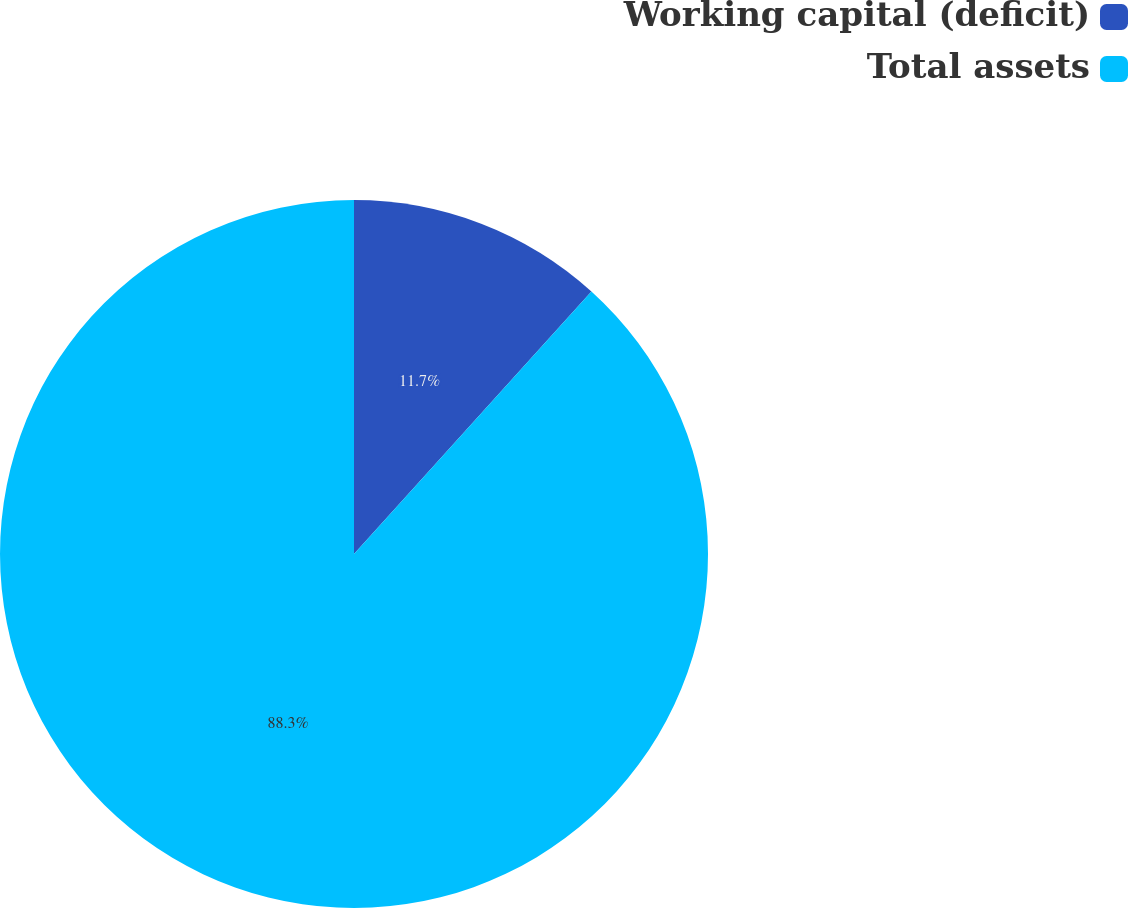Convert chart. <chart><loc_0><loc_0><loc_500><loc_500><pie_chart><fcel>Working capital (deficit)<fcel>Total assets<nl><fcel>11.7%<fcel>88.3%<nl></chart> 